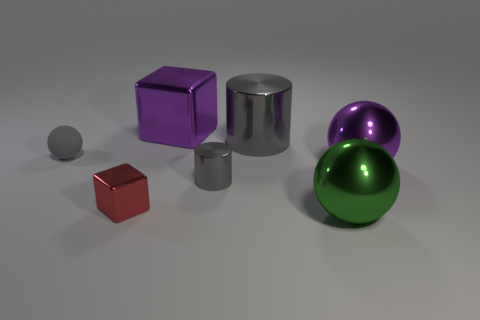Subtract all small spheres. How many spheres are left? 2 Subtract 1 balls. How many balls are left? 2 Add 1 yellow shiny objects. How many objects exist? 8 Subtract all cyan balls. Subtract all cyan cubes. How many balls are left? 3 Subtract all balls. How many objects are left? 4 Subtract all gray matte objects. Subtract all small rubber spheres. How many objects are left? 5 Add 1 tiny gray things. How many tiny gray things are left? 3 Add 1 red metal blocks. How many red metal blocks exist? 2 Subtract 1 red blocks. How many objects are left? 6 